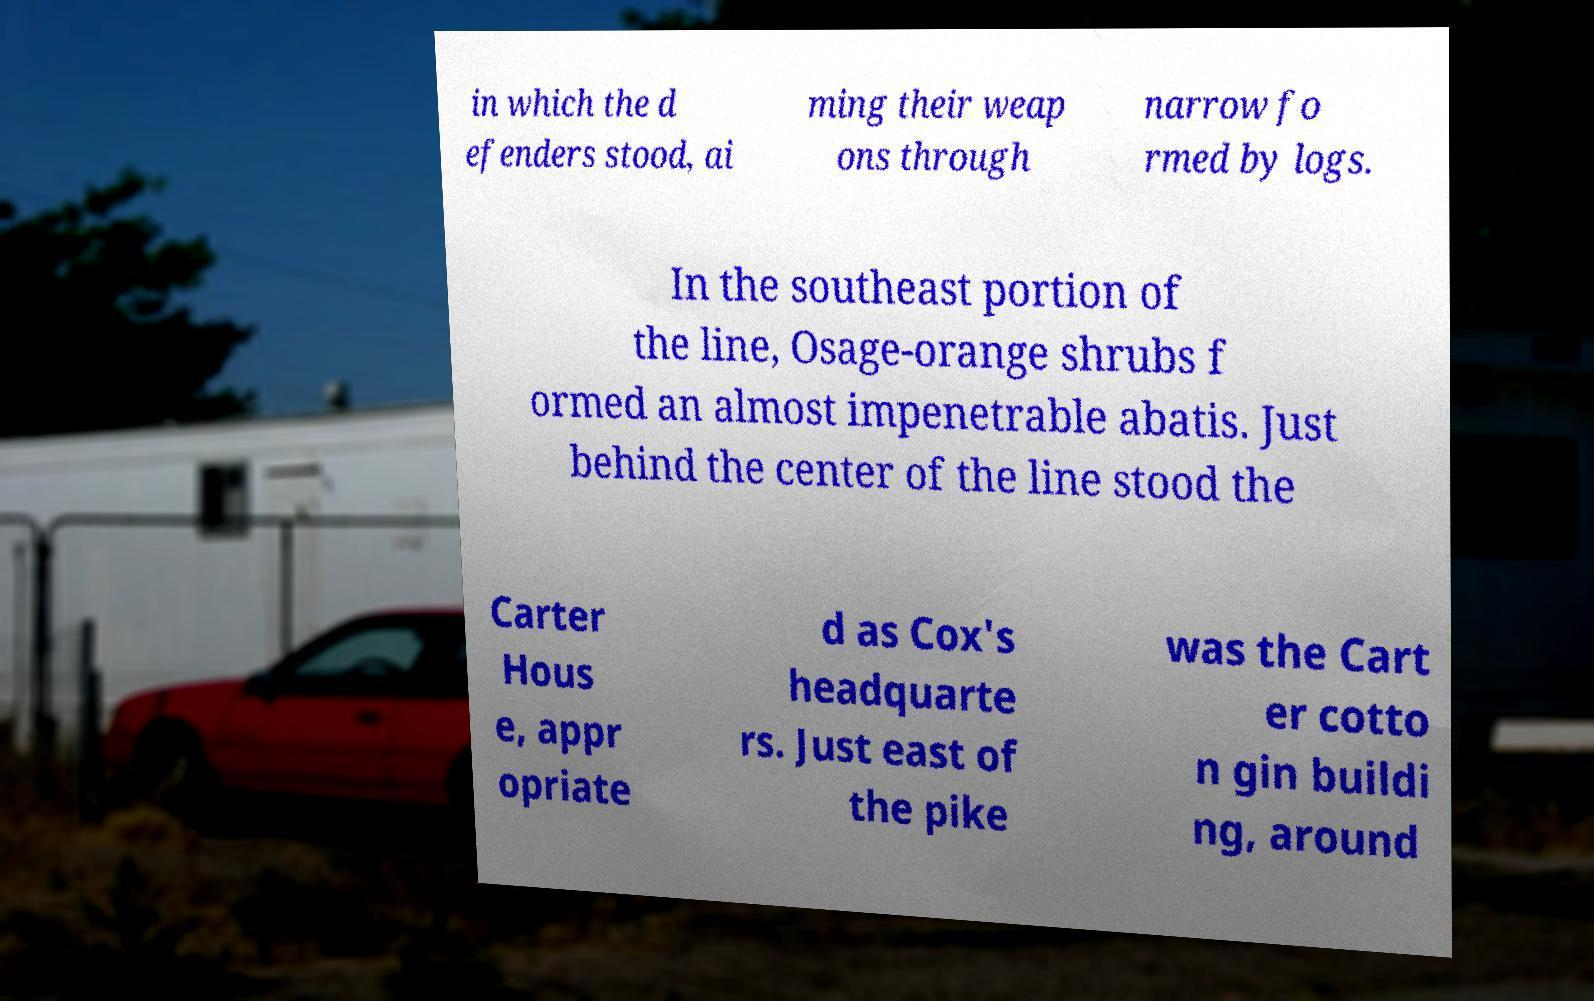I need the written content from this picture converted into text. Can you do that? in which the d efenders stood, ai ming their weap ons through narrow fo rmed by logs. In the southeast portion of the line, Osage-orange shrubs f ormed an almost impenetrable abatis. Just behind the center of the line stood the Carter Hous e, appr opriate d as Cox's headquarte rs. Just east of the pike was the Cart er cotto n gin buildi ng, around 